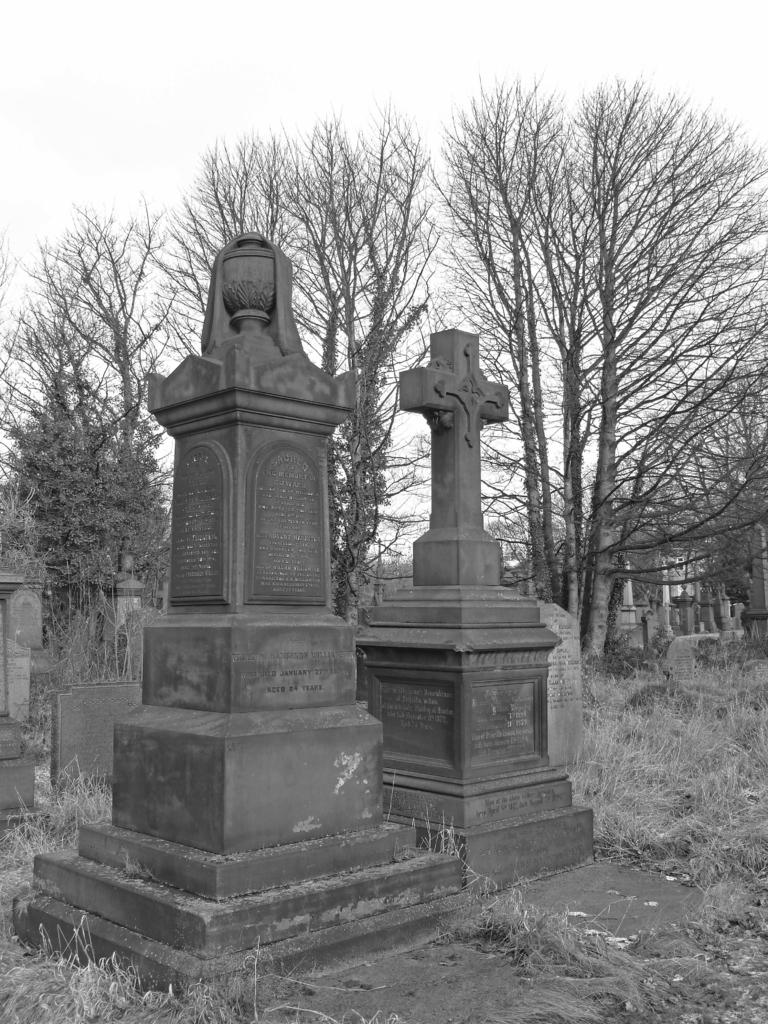What is the color scheme of the image? The image is black and white. What type of structures are present in the image? There are memorials in the image. What type of vegetation can be seen in the image? There is grass in the image. Are there any other natural elements visible in the image? Yes, there are trees in the image. What can be seen in the background of the image? The sky is visible in the background of the image. What type of farm animals can be seen grazing in the image? There are no farm animals present in the image; it features memorials, grass, trees, and a black and white color scheme. What type of disease is being treated in the image? There is no indication of any disease or medical treatment in the image. 